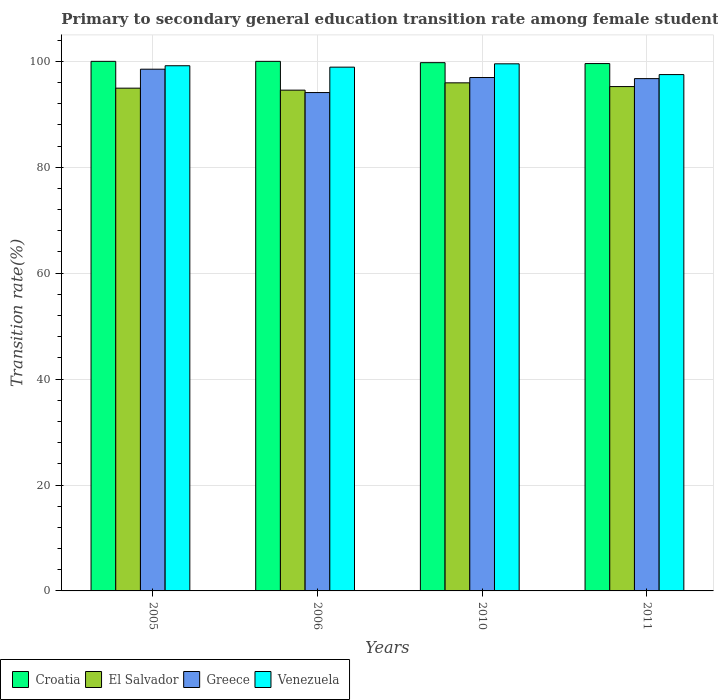Are the number of bars on each tick of the X-axis equal?
Your answer should be compact. Yes. What is the transition rate in El Salvador in 2010?
Give a very brief answer. 95.94. Across all years, what is the maximum transition rate in Greece?
Provide a short and direct response. 98.52. Across all years, what is the minimum transition rate in Croatia?
Offer a terse response. 99.58. In which year was the transition rate in Croatia minimum?
Make the answer very short. 2011. What is the total transition rate in Croatia in the graph?
Ensure brevity in your answer.  399.33. What is the difference between the transition rate in Greece in 2005 and that in 2006?
Ensure brevity in your answer.  4.41. What is the difference between the transition rate in Croatia in 2010 and the transition rate in Greece in 2006?
Provide a short and direct response. 5.65. What is the average transition rate in Venezuela per year?
Offer a very short reply. 98.78. In the year 2006, what is the difference between the transition rate in Croatia and transition rate in Greece?
Offer a very short reply. 5.89. In how many years, is the transition rate in Greece greater than 20 %?
Provide a succinct answer. 4. What is the ratio of the transition rate in El Salvador in 2010 to that in 2011?
Offer a very short reply. 1.01. Is the transition rate in Croatia in 2006 less than that in 2011?
Provide a short and direct response. No. Is the difference between the transition rate in Croatia in 2006 and 2010 greater than the difference between the transition rate in Greece in 2006 and 2010?
Make the answer very short. Yes. What is the difference between the highest and the second highest transition rate in El Salvador?
Provide a succinct answer. 0.71. What is the difference between the highest and the lowest transition rate in Greece?
Your answer should be compact. 4.41. What does the 4th bar from the left in 2011 represents?
Offer a terse response. Venezuela. How many bars are there?
Your response must be concise. 16. Are all the bars in the graph horizontal?
Your answer should be very brief. No. How many years are there in the graph?
Your answer should be very brief. 4. What is the difference between two consecutive major ticks on the Y-axis?
Provide a succinct answer. 20. Does the graph contain grids?
Your answer should be compact. Yes. How are the legend labels stacked?
Offer a very short reply. Horizontal. What is the title of the graph?
Give a very brief answer. Primary to secondary general education transition rate among female students. What is the label or title of the X-axis?
Give a very brief answer. Years. What is the label or title of the Y-axis?
Make the answer very short. Transition rate(%). What is the Transition rate(%) in Croatia in 2005?
Offer a terse response. 100. What is the Transition rate(%) of El Salvador in 2005?
Give a very brief answer. 94.94. What is the Transition rate(%) in Greece in 2005?
Your response must be concise. 98.52. What is the Transition rate(%) of Venezuela in 2005?
Ensure brevity in your answer.  99.17. What is the Transition rate(%) of Croatia in 2006?
Keep it short and to the point. 100. What is the Transition rate(%) of El Salvador in 2006?
Provide a short and direct response. 94.56. What is the Transition rate(%) of Greece in 2006?
Your answer should be compact. 94.11. What is the Transition rate(%) in Venezuela in 2006?
Provide a short and direct response. 98.91. What is the Transition rate(%) of Croatia in 2010?
Provide a short and direct response. 99.75. What is the Transition rate(%) in El Salvador in 2010?
Offer a very short reply. 95.94. What is the Transition rate(%) of Greece in 2010?
Give a very brief answer. 96.95. What is the Transition rate(%) of Venezuela in 2010?
Ensure brevity in your answer.  99.53. What is the Transition rate(%) of Croatia in 2011?
Keep it short and to the point. 99.58. What is the Transition rate(%) in El Salvador in 2011?
Ensure brevity in your answer.  95.24. What is the Transition rate(%) in Greece in 2011?
Offer a terse response. 96.74. What is the Transition rate(%) in Venezuela in 2011?
Give a very brief answer. 97.5. Across all years, what is the maximum Transition rate(%) in Croatia?
Your response must be concise. 100. Across all years, what is the maximum Transition rate(%) in El Salvador?
Your response must be concise. 95.94. Across all years, what is the maximum Transition rate(%) of Greece?
Offer a very short reply. 98.52. Across all years, what is the maximum Transition rate(%) in Venezuela?
Keep it short and to the point. 99.53. Across all years, what is the minimum Transition rate(%) in Croatia?
Keep it short and to the point. 99.58. Across all years, what is the minimum Transition rate(%) of El Salvador?
Offer a very short reply. 94.56. Across all years, what is the minimum Transition rate(%) of Greece?
Your answer should be very brief. 94.11. Across all years, what is the minimum Transition rate(%) of Venezuela?
Make the answer very short. 97.5. What is the total Transition rate(%) in Croatia in the graph?
Ensure brevity in your answer.  399.33. What is the total Transition rate(%) of El Salvador in the graph?
Make the answer very short. 380.68. What is the total Transition rate(%) in Greece in the graph?
Your response must be concise. 386.31. What is the total Transition rate(%) of Venezuela in the graph?
Offer a terse response. 395.11. What is the difference between the Transition rate(%) of Croatia in 2005 and that in 2006?
Provide a short and direct response. 0. What is the difference between the Transition rate(%) in El Salvador in 2005 and that in 2006?
Provide a short and direct response. 0.37. What is the difference between the Transition rate(%) of Greece in 2005 and that in 2006?
Provide a short and direct response. 4.41. What is the difference between the Transition rate(%) in Venezuela in 2005 and that in 2006?
Give a very brief answer. 0.27. What is the difference between the Transition rate(%) of Croatia in 2005 and that in 2010?
Provide a short and direct response. 0.25. What is the difference between the Transition rate(%) of El Salvador in 2005 and that in 2010?
Your response must be concise. -1.01. What is the difference between the Transition rate(%) in Greece in 2005 and that in 2010?
Provide a short and direct response. 1.57. What is the difference between the Transition rate(%) in Venezuela in 2005 and that in 2010?
Provide a short and direct response. -0.36. What is the difference between the Transition rate(%) of Croatia in 2005 and that in 2011?
Give a very brief answer. 0.42. What is the difference between the Transition rate(%) of El Salvador in 2005 and that in 2011?
Offer a very short reply. -0.3. What is the difference between the Transition rate(%) in Greece in 2005 and that in 2011?
Your answer should be compact. 1.78. What is the difference between the Transition rate(%) in Venezuela in 2005 and that in 2011?
Your answer should be compact. 1.67. What is the difference between the Transition rate(%) in Croatia in 2006 and that in 2010?
Ensure brevity in your answer.  0.25. What is the difference between the Transition rate(%) in El Salvador in 2006 and that in 2010?
Your answer should be compact. -1.38. What is the difference between the Transition rate(%) in Greece in 2006 and that in 2010?
Offer a terse response. -2.84. What is the difference between the Transition rate(%) in Venezuela in 2006 and that in 2010?
Your response must be concise. -0.63. What is the difference between the Transition rate(%) of Croatia in 2006 and that in 2011?
Your response must be concise. 0.42. What is the difference between the Transition rate(%) of El Salvador in 2006 and that in 2011?
Make the answer very short. -0.68. What is the difference between the Transition rate(%) in Greece in 2006 and that in 2011?
Keep it short and to the point. -2.63. What is the difference between the Transition rate(%) in Venezuela in 2006 and that in 2011?
Ensure brevity in your answer.  1.41. What is the difference between the Transition rate(%) of Croatia in 2010 and that in 2011?
Keep it short and to the point. 0.17. What is the difference between the Transition rate(%) of El Salvador in 2010 and that in 2011?
Provide a short and direct response. 0.71. What is the difference between the Transition rate(%) of Greece in 2010 and that in 2011?
Offer a very short reply. 0.21. What is the difference between the Transition rate(%) in Venezuela in 2010 and that in 2011?
Your response must be concise. 2.03. What is the difference between the Transition rate(%) of Croatia in 2005 and the Transition rate(%) of El Salvador in 2006?
Your answer should be very brief. 5.44. What is the difference between the Transition rate(%) of Croatia in 2005 and the Transition rate(%) of Greece in 2006?
Ensure brevity in your answer.  5.89. What is the difference between the Transition rate(%) in Croatia in 2005 and the Transition rate(%) in Venezuela in 2006?
Your answer should be compact. 1.09. What is the difference between the Transition rate(%) in El Salvador in 2005 and the Transition rate(%) in Greece in 2006?
Make the answer very short. 0.83. What is the difference between the Transition rate(%) of El Salvador in 2005 and the Transition rate(%) of Venezuela in 2006?
Your answer should be compact. -3.97. What is the difference between the Transition rate(%) of Greece in 2005 and the Transition rate(%) of Venezuela in 2006?
Your response must be concise. -0.39. What is the difference between the Transition rate(%) in Croatia in 2005 and the Transition rate(%) in El Salvador in 2010?
Ensure brevity in your answer.  4.06. What is the difference between the Transition rate(%) of Croatia in 2005 and the Transition rate(%) of Greece in 2010?
Offer a terse response. 3.05. What is the difference between the Transition rate(%) in Croatia in 2005 and the Transition rate(%) in Venezuela in 2010?
Give a very brief answer. 0.47. What is the difference between the Transition rate(%) of El Salvador in 2005 and the Transition rate(%) of Greece in 2010?
Offer a very short reply. -2.01. What is the difference between the Transition rate(%) of El Salvador in 2005 and the Transition rate(%) of Venezuela in 2010?
Your answer should be very brief. -4.6. What is the difference between the Transition rate(%) of Greece in 2005 and the Transition rate(%) of Venezuela in 2010?
Provide a succinct answer. -1.01. What is the difference between the Transition rate(%) of Croatia in 2005 and the Transition rate(%) of El Salvador in 2011?
Give a very brief answer. 4.76. What is the difference between the Transition rate(%) of Croatia in 2005 and the Transition rate(%) of Greece in 2011?
Your response must be concise. 3.26. What is the difference between the Transition rate(%) of Croatia in 2005 and the Transition rate(%) of Venezuela in 2011?
Ensure brevity in your answer.  2.5. What is the difference between the Transition rate(%) of El Salvador in 2005 and the Transition rate(%) of Greece in 2011?
Offer a terse response. -1.8. What is the difference between the Transition rate(%) of El Salvador in 2005 and the Transition rate(%) of Venezuela in 2011?
Offer a very short reply. -2.56. What is the difference between the Transition rate(%) of Greece in 2005 and the Transition rate(%) of Venezuela in 2011?
Your answer should be very brief. 1.02. What is the difference between the Transition rate(%) in Croatia in 2006 and the Transition rate(%) in El Salvador in 2010?
Provide a succinct answer. 4.06. What is the difference between the Transition rate(%) of Croatia in 2006 and the Transition rate(%) of Greece in 2010?
Keep it short and to the point. 3.05. What is the difference between the Transition rate(%) of Croatia in 2006 and the Transition rate(%) of Venezuela in 2010?
Keep it short and to the point. 0.47. What is the difference between the Transition rate(%) of El Salvador in 2006 and the Transition rate(%) of Greece in 2010?
Ensure brevity in your answer.  -2.38. What is the difference between the Transition rate(%) of El Salvador in 2006 and the Transition rate(%) of Venezuela in 2010?
Provide a short and direct response. -4.97. What is the difference between the Transition rate(%) in Greece in 2006 and the Transition rate(%) in Venezuela in 2010?
Make the answer very short. -5.43. What is the difference between the Transition rate(%) in Croatia in 2006 and the Transition rate(%) in El Salvador in 2011?
Your answer should be compact. 4.76. What is the difference between the Transition rate(%) of Croatia in 2006 and the Transition rate(%) of Greece in 2011?
Keep it short and to the point. 3.26. What is the difference between the Transition rate(%) of Croatia in 2006 and the Transition rate(%) of Venezuela in 2011?
Give a very brief answer. 2.5. What is the difference between the Transition rate(%) in El Salvador in 2006 and the Transition rate(%) in Greece in 2011?
Give a very brief answer. -2.18. What is the difference between the Transition rate(%) in El Salvador in 2006 and the Transition rate(%) in Venezuela in 2011?
Provide a short and direct response. -2.94. What is the difference between the Transition rate(%) in Greece in 2006 and the Transition rate(%) in Venezuela in 2011?
Keep it short and to the point. -3.39. What is the difference between the Transition rate(%) of Croatia in 2010 and the Transition rate(%) of El Salvador in 2011?
Keep it short and to the point. 4.51. What is the difference between the Transition rate(%) of Croatia in 2010 and the Transition rate(%) of Greece in 2011?
Provide a short and direct response. 3.01. What is the difference between the Transition rate(%) in Croatia in 2010 and the Transition rate(%) in Venezuela in 2011?
Offer a very short reply. 2.25. What is the difference between the Transition rate(%) in El Salvador in 2010 and the Transition rate(%) in Greece in 2011?
Offer a very short reply. -0.8. What is the difference between the Transition rate(%) in El Salvador in 2010 and the Transition rate(%) in Venezuela in 2011?
Ensure brevity in your answer.  -1.56. What is the difference between the Transition rate(%) of Greece in 2010 and the Transition rate(%) of Venezuela in 2011?
Your response must be concise. -0.55. What is the average Transition rate(%) of Croatia per year?
Offer a very short reply. 99.83. What is the average Transition rate(%) of El Salvador per year?
Offer a very short reply. 95.17. What is the average Transition rate(%) in Greece per year?
Keep it short and to the point. 96.58. What is the average Transition rate(%) in Venezuela per year?
Your answer should be very brief. 98.78. In the year 2005, what is the difference between the Transition rate(%) in Croatia and Transition rate(%) in El Salvador?
Offer a terse response. 5.06. In the year 2005, what is the difference between the Transition rate(%) of Croatia and Transition rate(%) of Greece?
Your answer should be compact. 1.48. In the year 2005, what is the difference between the Transition rate(%) of Croatia and Transition rate(%) of Venezuela?
Your response must be concise. 0.83. In the year 2005, what is the difference between the Transition rate(%) of El Salvador and Transition rate(%) of Greece?
Offer a terse response. -3.58. In the year 2005, what is the difference between the Transition rate(%) of El Salvador and Transition rate(%) of Venezuela?
Offer a terse response. -4.23. In the year 2005, what is the difference between the Transition rate(%) of Greece and Transition rate(%) of Venezuela?
Ensure brevity in your answer.  -0.65. In the year 2006, what is the difference between the Transition rate(%) in Croatia and Transition rate(%) in El Salvador?
Provide a succinct answer. 5.44. In the year 2006, what is the difference between the Transition rate(%) in Croatia and Transition rate(%) in Greece?
Your response must be concise. 5.89. In the year 2006, what is the difference between the Transition rate(%) of Croatia and Transition rate(%) of Venezuela?
Give a very brief answer. 1.09. In the year 2006, what is the difference between the Transition rate(%) in El Salvador and Transition rate(%) in Greece?
Your response must be concise. 0.46. In the year 2006, what is the difference between the Transition rate(%) of El Salvador and Transition rate(%) of Venezuela?
Your answer should be very brief. -4.34. In the year 2006, what is the difference between the Transition rate(%) in Greece and Transition rate(%) in Venezuela?
Your answer should be compact. -4.8. In the year 2010, what is the difference between the Transition rate(%) of Croatia and Transition rate(%) of El Salvador?
Provide a succinct answer. 3.81. In the year 2010, what is the difference between the Transition rate(%) in Croatia and Transition rate(%) in Greece?
Ensure brevity in your answer.  2.81. In the year 2010, what is the difference between the Transition rate(%) of Croatia and Transition rate(%) of Venezuela?
Your answer should be compact. 0.22. In the year 2010, what is the difference between the Transition rate(%) in El Salvador and Transition rate(%) in Greece?
Provide a short and direct response. -1. In the year 2010, what is the difference between the Transition rate(%) of El Salvador and Transition rate(%) of Venezuela?
Make the answer very short. -3.59. In the year 2010, what is the difference between the Transition rate(%) in Greece and Transition rate(%) in Venezuela?
Provide a short and direct response. -2.59. In the year 2011, what is the difference between the Transition rate(%) in Croatia and Transition rate(%) in El Salvador?
Keep it short and to the point. 4.34. In the year 2011, what is the difference between the Transition rate(%) in Croatia and Transition rate(%) in Greece?
Keep it short and to the point. 2.84. In the year 2011, what is the difference between the Transition rate(%) of Croatia and Transition rate(%) of Venezuela?
Offer a terse response. 2.08. In the year 2011, what is the difference between the Transition rate(%) in El Salvador and Transition rate(%) in Greece?
Keep it short and to the point. -1.5. In the year 2011, what is the difference between the Transition rate(%) in El Salvador and Transition rate(%) in Venezuela?
Keep it short and to the point. -2.26. In the year 2011, what is the difference between the Transition rate(%) in Greece and Transition rate(%) in Venezuela?
Ensure brevity in your answer.  -0.76. What is the ratio of the Transition rate(%) of El Salvador in 2005 to that in 2006?
Provide a succinct answer. 1. What is the ratio of the Transition rate(%) in Greece in 2005 to that in 2006?
Ensure brevity in your answer.  1.05. What is the ratio of the Transition rate(%) in Venezuela in 2005 to that in 2006?
Keep it short and to the point. 1. What is the ratio of the Transition rate(%) in Greece in 2005 to that in 2010?
Make the answer very short. 1.02. What is the ratio of the Transition rate(%) in Greece in 2005 to that in 2011?
Ensure brevity in your answer.  1.02. What is the ratio of the Transition rate(%) of Venezuela in 2005 to that in 2011?
Make the answer very short. 1.02. What is the ratio of the Transition rate(%) of El Salvador in 2006 to that in 2010?
Make the answer very short. 0.99. What is the ratio of the Transition rate(%) in Greece in 2006 to that in 2010?
Provide a succinct answer. 0.97. What is the ratio of the Transition rate(%) of Venezuela in 2006 to that in 2010?
Offer a very short reply. 0.99. What is the ratio of the Transition rate(%) in Croatia in 2006 to that in 2011?
Keep it short and to the point. 1. What is the ratio of the Transition rate(%) in El Salvador in 2006 to that in 2011?
Keep it short and to the point. 0.99. What is the ratio of the Transition rate(%) in Greece in 2006 to that in 2011?
Provide a succinct answer. 0.97. What is the ratio of the Transition rate(%) of Venezuela in 2006 to that in 2011?
Give a very brief answer. 1.01. What is the ratio of the Transition rate(%) of El Salvador in 2010 to that in 2011?
Provide a short and direct response. 1.01. What is the ratio of the Transition rate(%) of Venezuela in 2010 to that in 2011?
Make the answer very short. 1.02. What is the difference between the highest and the second highest Transition rate(%) of Croatia?
Give a very brief answer. 0. What is the difference between the highest and the second highest Transition rate(%) of El Salvador?
Your response must be concise. 0.71. What is the difference between the highest and the second highest Transition rate(%) of Greece?
Give a very brief answer. 1.57. What is the difference between the highest and the second highest Transition rate(%) in Venezuela?
Your answer should be compact. 0.36. What is the difference between the highest and the lowest Transition rate(%) in Croatia?
Give a very brief answer. 0.42. What is the difference between the highest and the lowest Transition rate(%) in El Salvador?
Give a very brief answer. 1.38. What is the difference between the highest and the lowest Transition rate(%) in Greece?
Your response must be concise. 4.41. What is the difference between the highest and the lowest Transition rate(%) in Venezuela?
Provide a short and direct response. 2.03. 